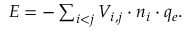<formula> <loc_0><loc_0><loc_500><loc_500>\begin{array} { r } { E = - \sum _ { i < j } V _ { i , j } \cdot n _ { i } \cdot q _ { e } . } \end{array}</formula> 